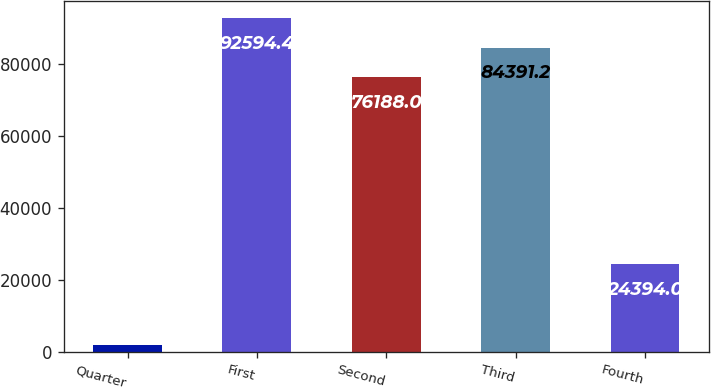Convert chart. <chart><loc_0><loc_0><loc_500><loc_500><bar_chart><fcel>Quarter<fcel>First<fcel>Second<fcel>Third<fcel>Fourth<nl><fcel>2011<fcel>92594.4<fcel>76188<fcel>84391.2<fcel>24394<nl></chart> 